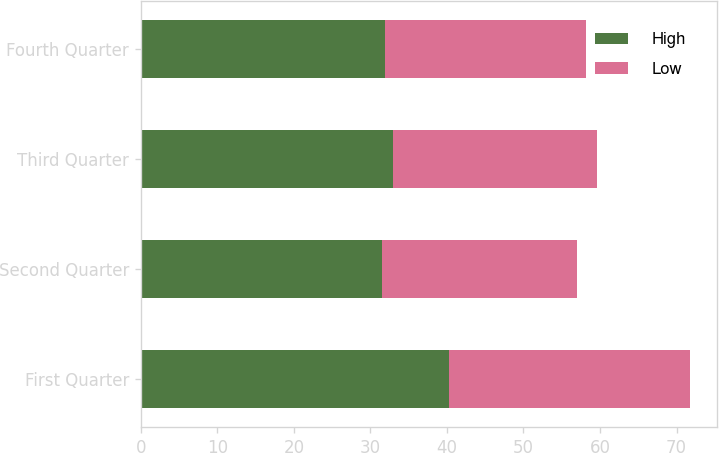Convert chart to OTSL. <chart><loc_0><loc_0><loc_500><loc_500><stacked_bar_chart><ecel><fcel>First Quarter<fcel>Second Quarter<fcel>Third Quarter<fcel>Fourth Quarter<nl><fcel>High<fcel>40.22<fcel>31.53<fcel>32.95<fcel>31.92<nl><fcel>Low<fcel>31.53<fcel>25.44<fcel>26.68<fcel>26.29<nl></chart> 